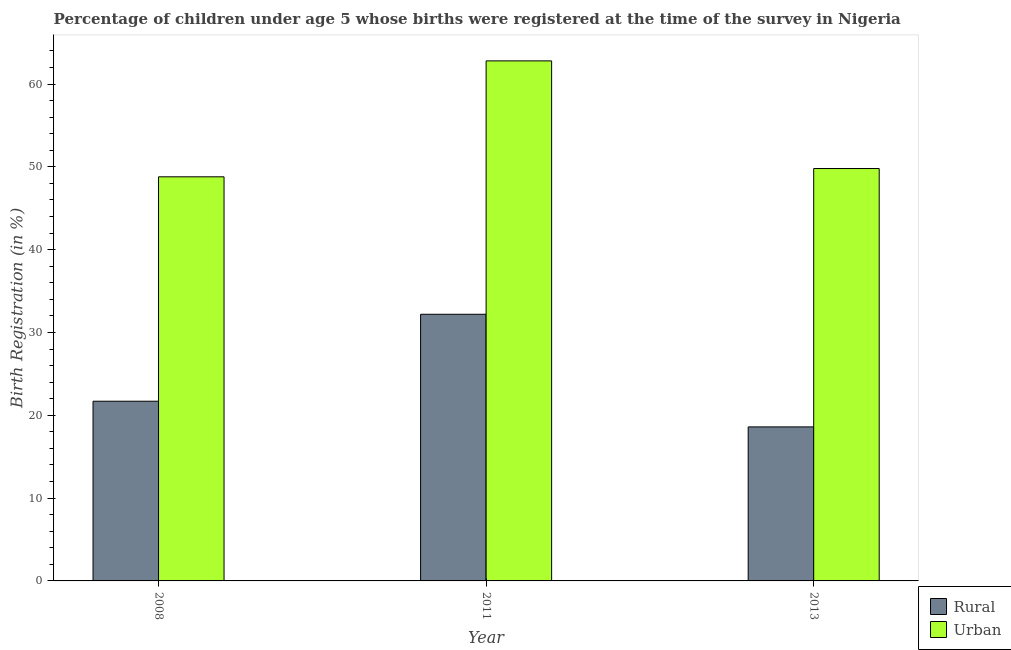How many different coloured bars are there?
Provide a short and direct response. 2. Are the number of bars per tick equal to the number of legend labels?
Your answer should be very brief. Yes. Are the number of bars on each tick of the X-axis equal?
Provide a succinct answer. Yes. How many bars are there on the 1st tick from the right?
Give a very brief answer. 2. In how many cases, is the number of bars for a given year not equal to the number of legend labels?
Provide a succinct answer. 0. What is the urban birth registration in 2011?
Your response must be concise. 62.8. Across all years, what is the maximum urban birth registration?
Your answer should be very brief. 62.8. Across all years, what is the minimum urban birth registration?
Provide a short and direct response. 48.8. In which year was the urban birth registration maximum?
Keep it short and to the point. 2011. What is the total urban birth registration in the graph?
Provide a short and direct response. 161.4. What is the difference between the urban birth registration in 2008 and that in 2013?
Your response must be concise. -1. What is the average rural birth registration per year?
Ensure brevity in your answer.  24.17. What is the ratio of the rural birth registration in 2008 to that in 2013?
Make the answer very short. 1.17. Is the rural birth registration in 2008 less than that in 2013?
Give a very brief answer. No. Is the difference between the urban birth registration in 2011 and 2013 greater than the difference between the rural birth registration in 2011 and 2013?
Ensure brevity in your answer.  No. What is the difference between the highest and the second highest urban birth registration?
Your response must be concise. 13. What is the difference between the highest and the lowest urban birth registration?
Your answer should be compact. 14. What does the 2nd bar from the left in 2011 represents?
Your answer should be compact. Urban. What does the 1st bar from the right in 2013 represents?
Make the answer very short. Urban. How many bars are there?
Provide a succinct answer. 6. Where does the legend appear in the graph?
Your answer should be very brief. Bottom right. What is the title of the graph?
Provide a succinct answer. Percentage of children under age 5 whose births were registered at the time of the survey in Nigeria. Does "Boys" appear as one of the legend labels in the graph?
Ensure brevity in your answer.  No. What is the label or title of the X-axis?
Make the answer very short. Year. What is the label or title of the Y-axis?
Keep it short and to the point. Birth Registration (in %). What is the Birth Registration (in %) in Rural in 2008?
Offer a terse response. 21.7. What is the Birth Registration (in %) in Urban in 2008?
Your answer should be compact. 48.8. What is the Birth Registration (in %) of Rural in 2011?
Provide a short and direct response. 32.2. What is the Birth Registration (in %) of Urban in 2011?
Your answer should be compact. 62.8. What is the Birth Registration (in %) in Urban in 2013?
Offer a very short reply. 49.8. Across all years, what is the maximum Birth Registration (in %) in Rural?
Your response must be concise. 32.2. Across all years, what is the maximum Birth Registration (in %) of Urban?
Offer a very short reply. 62.8. Across all years, what is the minimum Birth Registration (in %) in Rural?
Keep it short and to the point. 18.6. Across all years, what is the minimum Birth Registration (in %) of Urban?
Ensure brevity in your answer.  48.8. What is the total Birth Registration (in %) in Rural in the graph?
Your answer should be compact. 72.5. What is the total Birth Registration (in %) in Urban in the graph?
Provide a succinct answer. 161.4. What is the difference between the Birth Registration (in %) in Rural in 2008 and that in 2013?
Provide a succinct answer. 3.1. What is the difference between the Birth Registration (in %) in Urban in 2008 and that in 2013?
Your response must be concise. -1. What is the difference between the Birth Registration (in %) in Rural in 2008 and the Birth Registration (in %) in Urban in 2011?
Offer a terse response. -41.1. What is the difference between the Birth Registration (in %) of Rural in 2008 and the Birth Registration (in %) of Urban in 2013?
Give a very brief answer. -28.1. What is the difference between the Birth Registration (in %) in Rural in 2011 and the Birth Registration (in %) in Urban in 2013?
Offer a terse response. -17.6. What is the average Birth Registration (in %) of Rural per year?
Keep it short and to the point. 24.17. What is the average Birth Registration (in %) in Urban per year?
Your answer should be very brief. 53.8. In the year 2008, what is the difference between the Birth Registration (in %) in Rural and Birth Registration (in %) in Urban?
Your answer should be very brief. -27.1. In the year 2011, what is the difference between the Birth Registration (in %) in Rural and Birth Registration (in %) in Urban?
Your response must be concise. -30.6. In the year 2013, what is the difference between the Birth Registration (in %) of Rural and Birth Registration (in %) of Urban?
Provide a succinct answer. -31.2. What is the ratio of the Birth Registration (in %) of Rural in 2008 to that in 2011?
Provide a succinct answer. 0.67. What is the ratio of the Birth Registration (in %) in Urban in 2008 to that in 2011?
Give a very brief answer. 0.78. What is the ratio of the Birth Registration (in %) of Rural in 2008 to that in 2013?
Your answer should be compact. 1.17. What is the ratio of the Birth Registration (in %) of Urban in 2008 to that in 2013?
Keep it short and to the point. 0.98. What is the ratio of the Birth Registration (in %) of Rural in 2011 to that in 2013?
Offer a very short reply. 1.73. What is the ratio of the Birth Registration (in %) in Urban in 2011 to that in 2013?
Keep it short and to the point. 1.26. What is the difference between the highest and the second highest Birth Registration (in %) of Rural?
Offer a terse response. 10.5. What is the difference between the highest and the second highest Birth Registration (in %) of Urban?
Keep it short and to the point. 13. What is the difference between the highest and the lowest Birth Registration (in %) of Urban?
Offer a terse response. 14. 